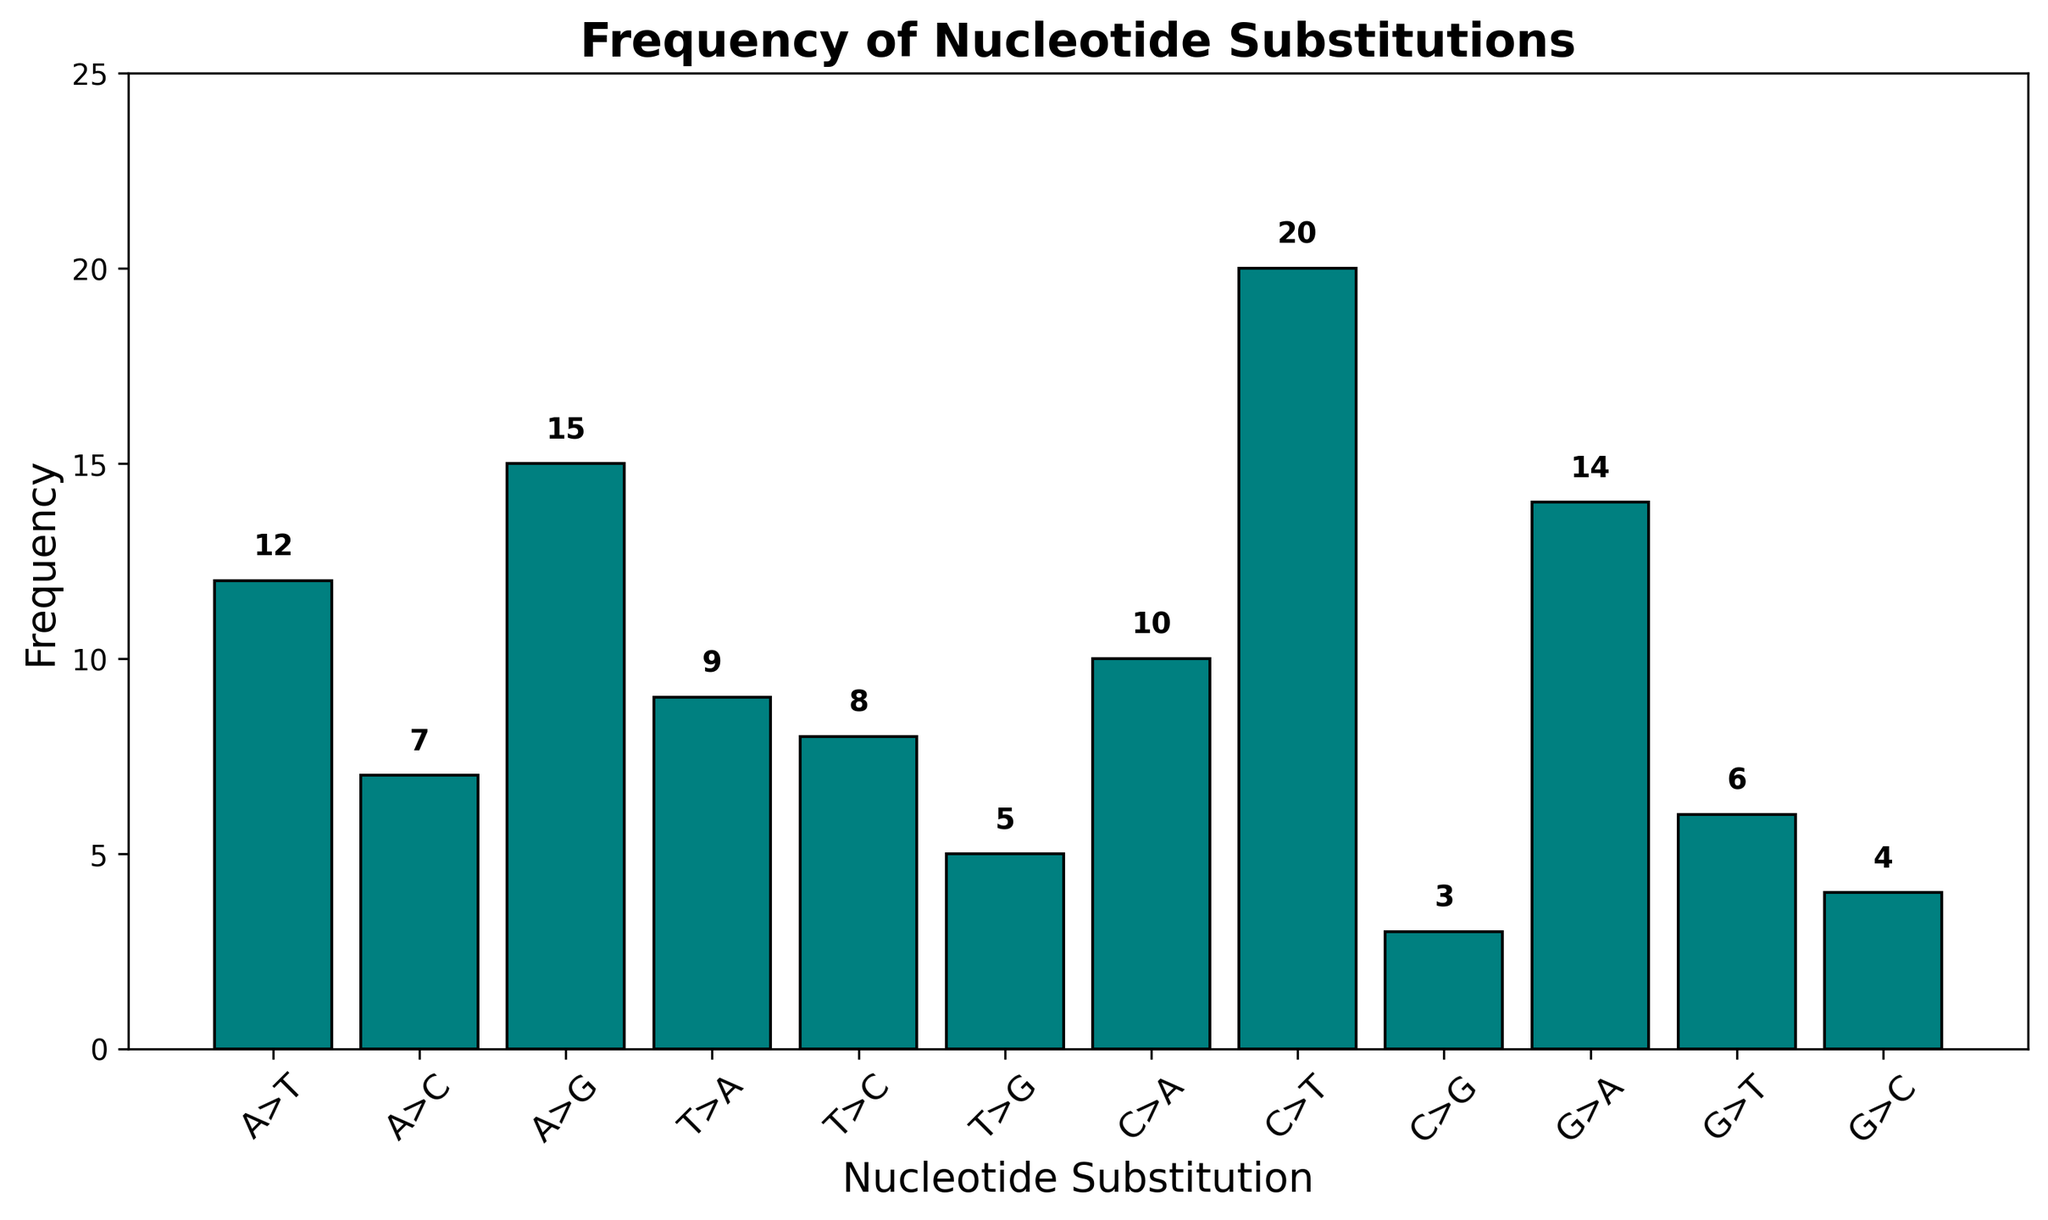What is the most frequent nucleotide substitution? First, identify which bar is the tallest. The tallest bar represents the most frequent substitution. By reading the label on the x-axis under the tallest bar, we see that "C>T" is the highest with a frequency of 20.
Answer: C>T What is the least frequent nucleotide substitution? Locate the shortest bar on the histogram. The shortest bar represents the least frequent substitution. The label on the x-axis under the shortest bar indicates "C>G" with a frequency of 3.
Answer: C>G What is the combined frequency of all transitions (A>G, G>A, C>T, T>C)? Sum the frequencies of the transitions: A>G (15), G>A (14), C>T (20), and T>C (8). The calculation is 15 + 14 + 20 + 8 which equals 57.
Answer: 57 Which has a higher frequency: transversions (A>T, C>G, etc.) or transitions (A>G, C>T, etc.)? First, calculate the total frequency of transversions: A>T (12), A>C (7), T>A (9), T>G (5), C>A (10), C>G (3), G>T (6), G>C (4). This sums to 12 + 7 + 9 + 5 + 10 + 3 + 6 + 4 = 56. Transitions total to 57 as calculated previously. Compare the sums: Transitions (57) > Transversions (56).
Answer: Transitions What is the difference in frequency between the most and least frequent nucleotide substitutions? Identify the most frequent substitution (C>T) with a frequency of 20 and the least frequent substitution (C>G) with a frequency of 3. Subtract the least frequent from the most frequent: 20 - 3 = 17.
Answer: 17 Are there more transitions involving purines (A>G, G>A) or pyrimidines (C>T, T>C)? Sum the frequencies of purine transitions: A>G (15) + G>A (14) = 29. Sum the frequencies of pyrimidine transitions: C>T (20) + T>C (8) = 28. Compare the sums: Purine transitions (29) > Pyrimidine transitions (28).
Answer: Purine transitions What is the average frequency of all nucleotide substitutions? Sum all the frequencies and then divide by the number of substitution types (12). The sum of the frequencies is 12 + 7 + 15 + 9 + 8 + 5 + 10 + 20 + 3 + 14 + 6 + 4 = 113. Divide this by 12: 113 / 12 ≈ 9.42.
Answer: 9.42 How does the frequency of A>G compare to G>A? Look at the heights of the bars for A>G and G>A. A>G has a frequency of 15, and G>A has a frequency of 14. Since 15 > 14, A>G is more frequent than G>A.
Answer: A>G What is the total frequency of substitutions involving A-nucleotides (A>T, A>C, A>G)? Add the frequencies of A>T (12), A>C (7), and A>G (15): 12 + 7 + 15 = 34.
Answer: 34 